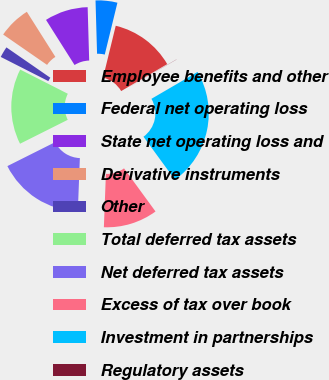Convert chart. <chart><loc_0><loc_0><loc_500><loc_500><pie_chart><fcel>Employee benefits and other<fcel>Federal net operating loss<fcel>State net operating loss and<fcel>Derivative instruments<fcel>Other<fcel>Total deferred tax assets<fcel>Net deferred tax assets<fcel>Excess of tax over book<fcel>Investment in partnerships<fcel>Regulatory assets<nl><fcel>12.76%<fcel>4.27%<fcel>8.52%<fcel>6.39%<fcel>2.15%<fcel>14.88%<fcel>17.0%<fcel>10.64%<fcel>23.36%<fcel>0.03%<nl></chart> 